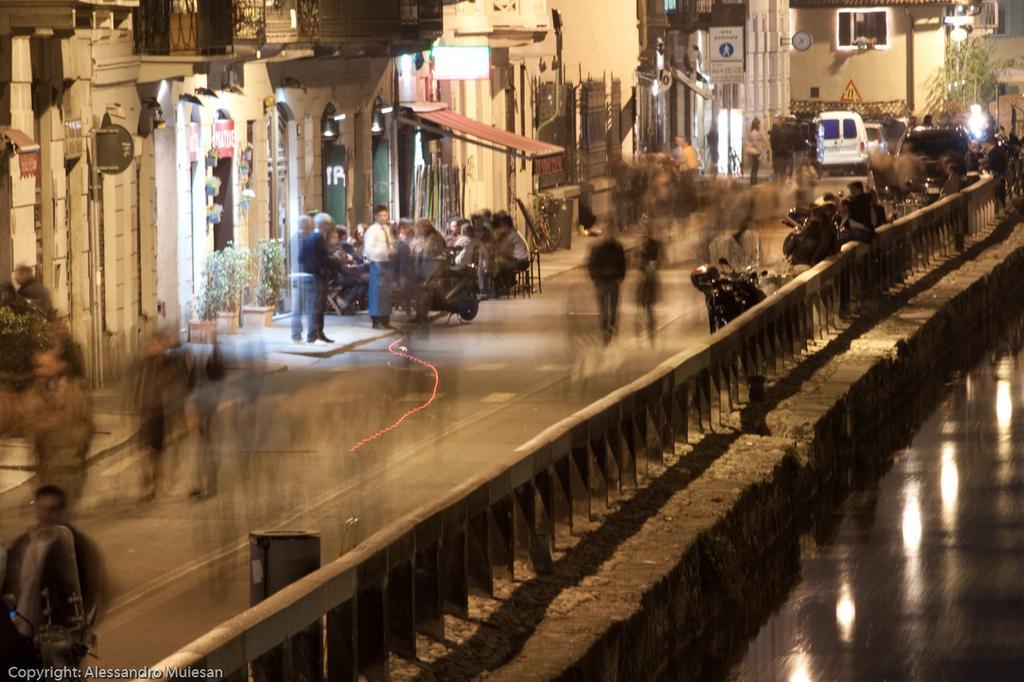In one or two sentences, can you explain what this image depicts? As we can see in the image there is water, fence, buildings, lights, few people here and there, poster and vehicle. 